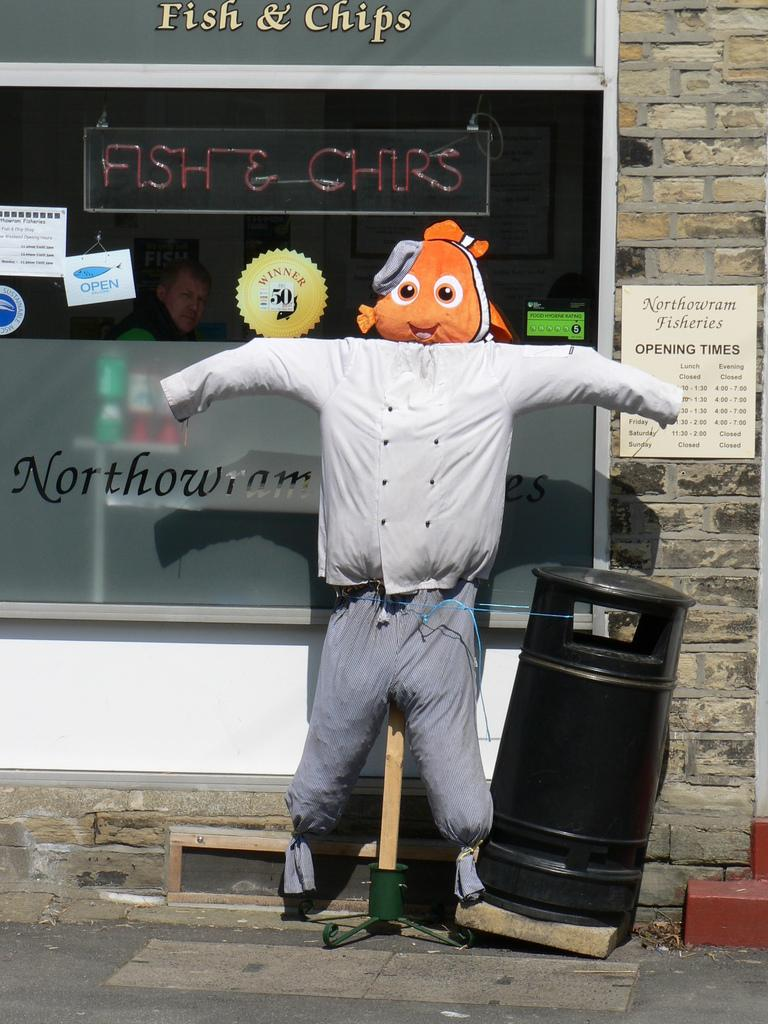<image>
Render a clear and concise summary of the photo. A store front with a sign that says fish & chips 